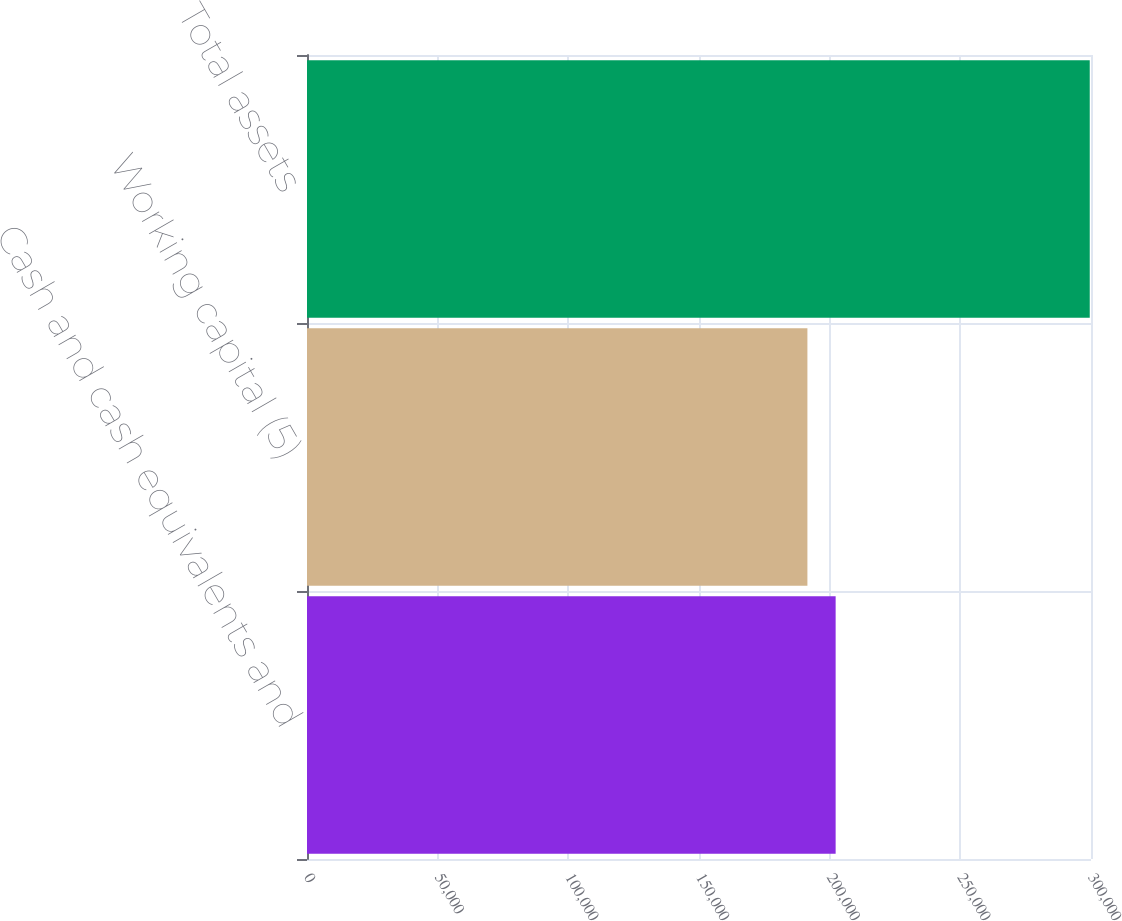Convert chart. <chart><loc_0><loc_0><loc_500><loc_500><bar_chart><fcel>Cash and cash equivalents and<fcel>Working capital (5)<fcel>Total assets<nl><fcel>202286<fcel>191482<fcel>299521<nl></chart> 